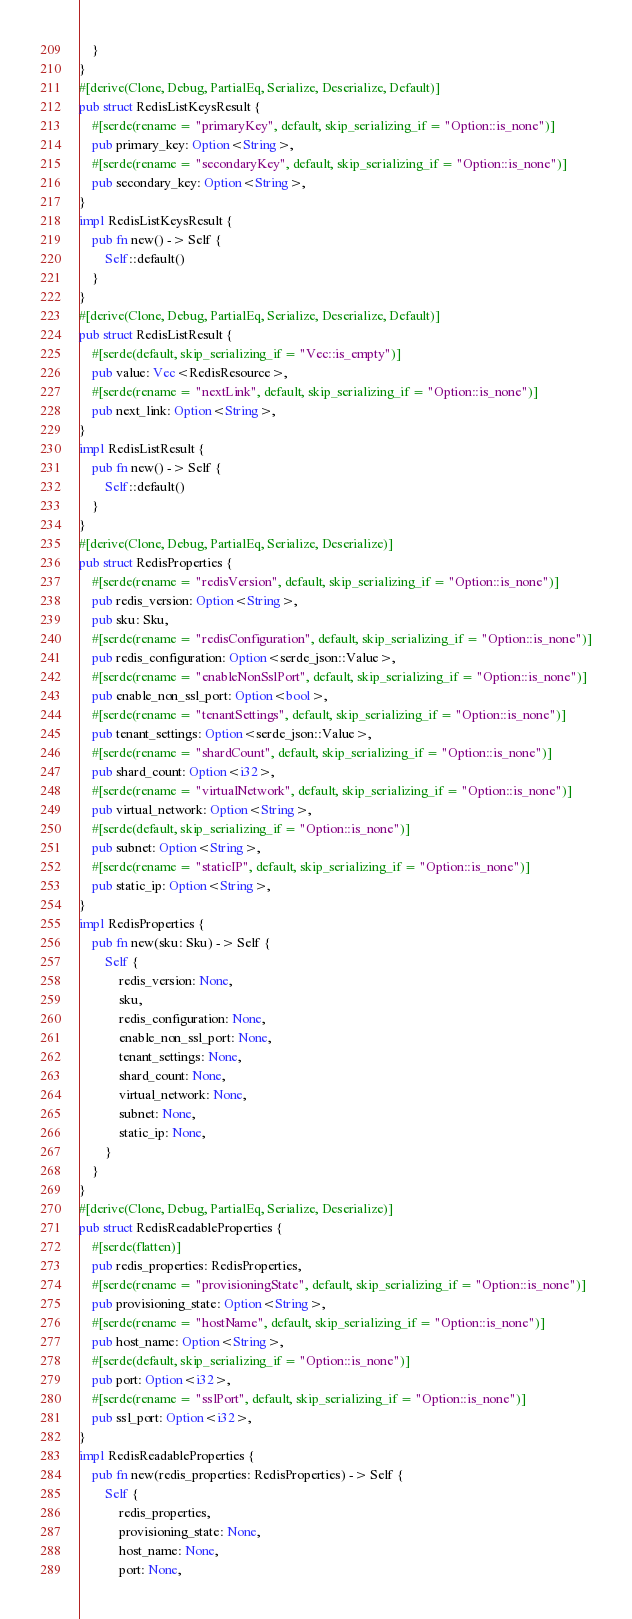Convert code to text. <code><loc_0><loc_0><loc_500><loc_500><_Rust_>    }
}
#[derive(Clone, Debug, PartialEq, Serialize, Deserialize, Default)]
pub struct RedisListKeysResult {
    #[serde(rename = "primaryKey", default, skip_serializing_if = "Option::is_none")]
    pub primary_key: Option<String>,
    #[serde(rename = "secondaryKey", default, skip_serializing_if = "Option::is_none")]
    pub secondary_key: Option<String>,
}
impl RedisListKeysResult {
    pub fn new() -> Self {
        Self::default()
    }
}
#[derive(Clone, Debug, PartialEq, Serialize, Deserialize, Default)]
pub struct RedisListResult {
    #[serde(default, skip_serializing_if = "Vec::is_empty")]
    pub value: Vec<RedisResource>,
    #[serde(rename = "nextLink", default, skip_serializing_if = "Option::is_none")]
    pub next_link: Option<String>,
}
impl RedisListResult {
    pub fn new() -> Self {
        Self::default()
    }
}
#[derive(Clone, Debug, PartialEq, Serialize, Deserialize)]
pub struct RedisProperties {
    #[serde(rename = "redisVersion", default, skip_serializing_if = "Option::is_none")]
    pub redis_version: Option<String>,
    pub sku: Sku,
    #[serde(rename = "redisConfiguration", default, skip_serializing_if = "Option::is_none")]
    pub redis_configuration: Option<serde_json::Value>,
    #[serde(rename = "enableNonSslPort", default, skip_serializing_if = "Option::is_none")]
    pub enable_non_ssl_port: Option<bool>,
    #[serde(rename = "tenantSettings", default, skip_serializing_if = "Option::is_none")]
    pub tenant_settings: Option<serde_json::Value>,
    #[serde(rename = "shardCount", default, skip_serializing_if = "Option::is_none")]
    pub shard_count: Option<i32>,
    #[serde(rename = "virtualNetwork", default, skip_serializing_if = "Option::is_none")]
    pub virtual_network: Option<String>,
    #[serde(default, skip_serializing_if = "Option::is_none")]
    pub subnet: Option<String>,
    #[serde(rename = "staticIP", default, skip_serializing_if = "Option::is_none")]
    pub static_ip: Option<String>,
}
impl RedisProperties {
    pub fn new(sku: Sku) -> Self {
        Self {
            redis_version: None,
            sku,
            redis_configuration: None,
            enable_non_ssl_port: None,
            tenant_settings: None,
            shard_count: None,
            virtual_network: None,
            subnet: None,
            static_ip: None,
        }
    }
}
#[derive(Clone, Debug, PartialEq, Serialize, Deserialize)]
pub struct RedisReadableProperties {
    #[serde(flatten)]
    pub redis_properties: RedisProperties,
    #[serde(rename = "provisioningState", default, skip_serializing_if = "Option::is_none")]
    pub provisioning_state: Option<String>,
    #[serde(rename = "hostName", default, skip_serializing_if = "Option::is_none")]
    pub host_name: Option<String>,
    #[serde(default, skip_serializing_if = "Option::is_none")]
    pub port: Option<i32>,
    #[serde(rename = "sslPort", default, skip_serializing_if = "Option::is_none")]
    pub ssl_port: Option<i32>,
}
impl RedisReadableProperties {
    pub fn new(redis_properties: RedisProperties) -> Self {
        Self {
            redis_properties,
            provisioning_state: None,
            host_name: None,
            port: None,</code> 